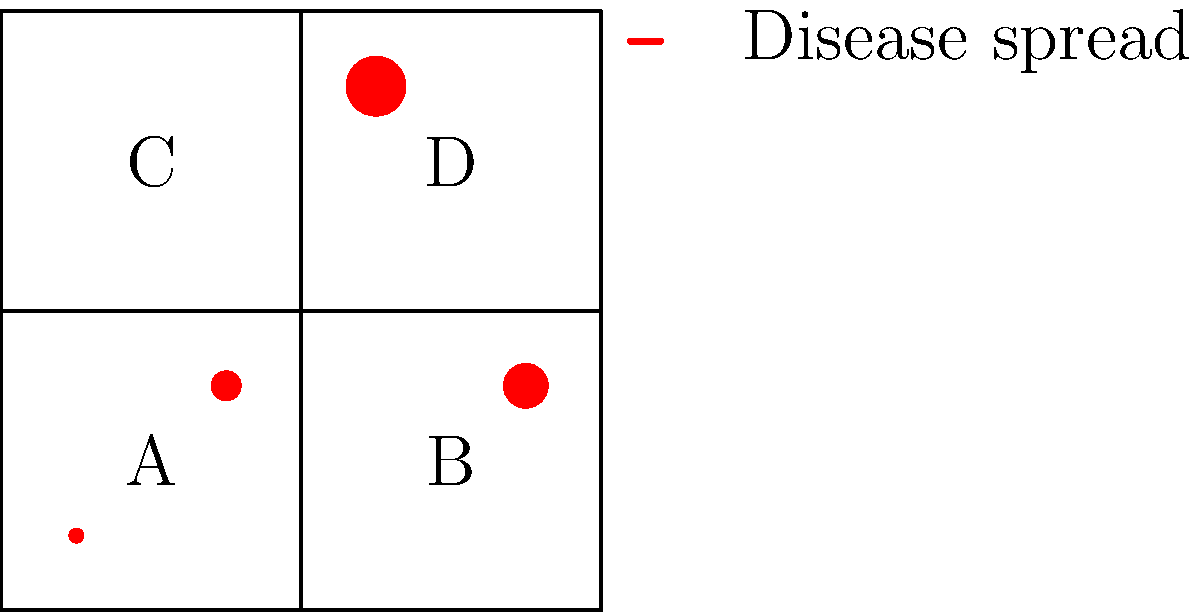Based on the geographical map showing disease spread patterns across four regions (A, B, C, and D), which region is most likely to be the next hotspot for the disease outbreak? To determine the next likely hotspot, we need to analyze the pattern of disease spread:

1. Observe the current spread:
   Region A: Small outbreak
   Region B: Medium outbreak
   Region C: No visible outbreak
   Region D: Large outbreak

2. Analyze the pattern:
   - The disease seems to be spreading from the bottom-left to the top-right.
   - The size of the outbreak increases in this direction.

3. Consider geographical proximity:
   - Region C is adjacent to both B and D, which have outbreaks.
   - Region C is the only area without a visible outbreak yet.

4. Apply epidemiological principles:
   - Diseases often spread to neighboring areas.
   - Areas without prior exposure are more vulnerable.

5. Conclusion:
   Region C is most likely to be the next hotspot because:
   a) It follows the diagonal spread pattern.
   b) It's adjacent to infected regions.
   c) It hasn't had a significant outbreak yet, making the population more susceptible.
Answer: Region C 